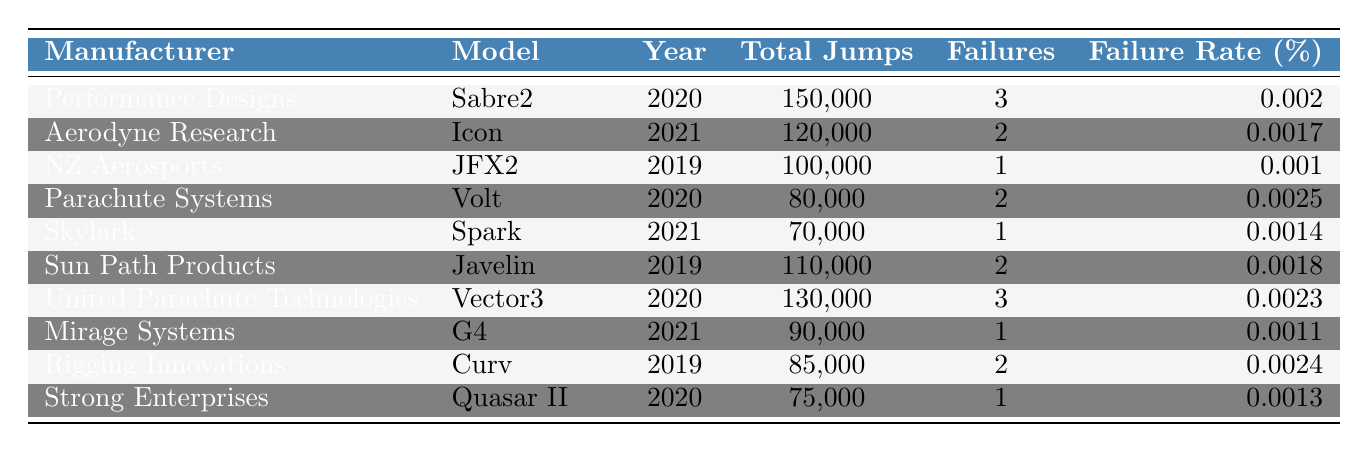What is the failure rate of the Sabre2 parachute? The failure rate of the Sabre2 parachute from Performance Designs, as shown in the table, is listed as 0.002%.
Answer: 0.002% Which parachute model has the highest total jumps? By comparing the "Total Jumps" column, the Sabre2 has the highest total jumps at 150,000.
Answer: Sabre2 What is the failure rate of the Javelin and how does it compare to the Volt? The Javelin has a failure rate of 0.0018%, while the Volt has 0.0025%. Since 0.0018% < 0.0025%, the Javelin has a lower failure rate than the Volt.
Answer: Javelin has a lower failure rate than Volt Which manufacturer has a failure rate of 0.0011%? By checking the table, the manufacture associated with a failure rate of 0.0011% is Mirage Systems with the G4 model.
Answer: Mirage Systems How many total jumps does the Vector3 have, and what percentage increase in jumps does it have compared to the Spark? The Vector3 has 130,000 total jumps and the Spark has 70,000. The difference in jumps is 130,000 - 70,000 = 60,000. The percentage increase is (60,000 / 70,000) * 100% = 85.71%.
Answer: 85.71% Is the failure rate of the Icon greater than the failure rate of the Quasar II? The Icon has a failure rate of 0.0017%, and the Quasar II has 0.0013%. Since 0.0017% > 0.0013%, the statement is true.
Answer: Yes How many manufacturers have a failure rate below 0.002%? Reviewing the failure rates, the following have rates below 0.002%: Icon (0.0017%), JFX2 (0.001%), Spark (0.0014%), and G4 (0.0011%). That totals to 4 manufacturers.
Answer: 4 What is the average failure rate across all models presented in the table? The failure rates are: 0.002, 0.0017, 0.001, 0.0025, 0.0014, 0.0018, 0.0023, 0.0011, 0.0024, and 0.0013. Summing these gives 0.002 + 0.0017 + 0.001 + 0.0025 + 0.0014 + 0.0018 + 0.0023 + 0.0011 + 0.0024 + 0.0013 = 0.0195; there are 10 models so the average is 0.0195 / 10 = 0.00195 or 0.195%.
Answer: 0.195% Which model has the highest number of failures and what is that number? The models that have the highest number of failures are Sabre2 and Vector3, both with 3 failures.
Answer: 3 failures Was the JFX2 model tested in 2020? The JFX2 model was tested in 2019, as noted in the year column of the table.
Answer: No 